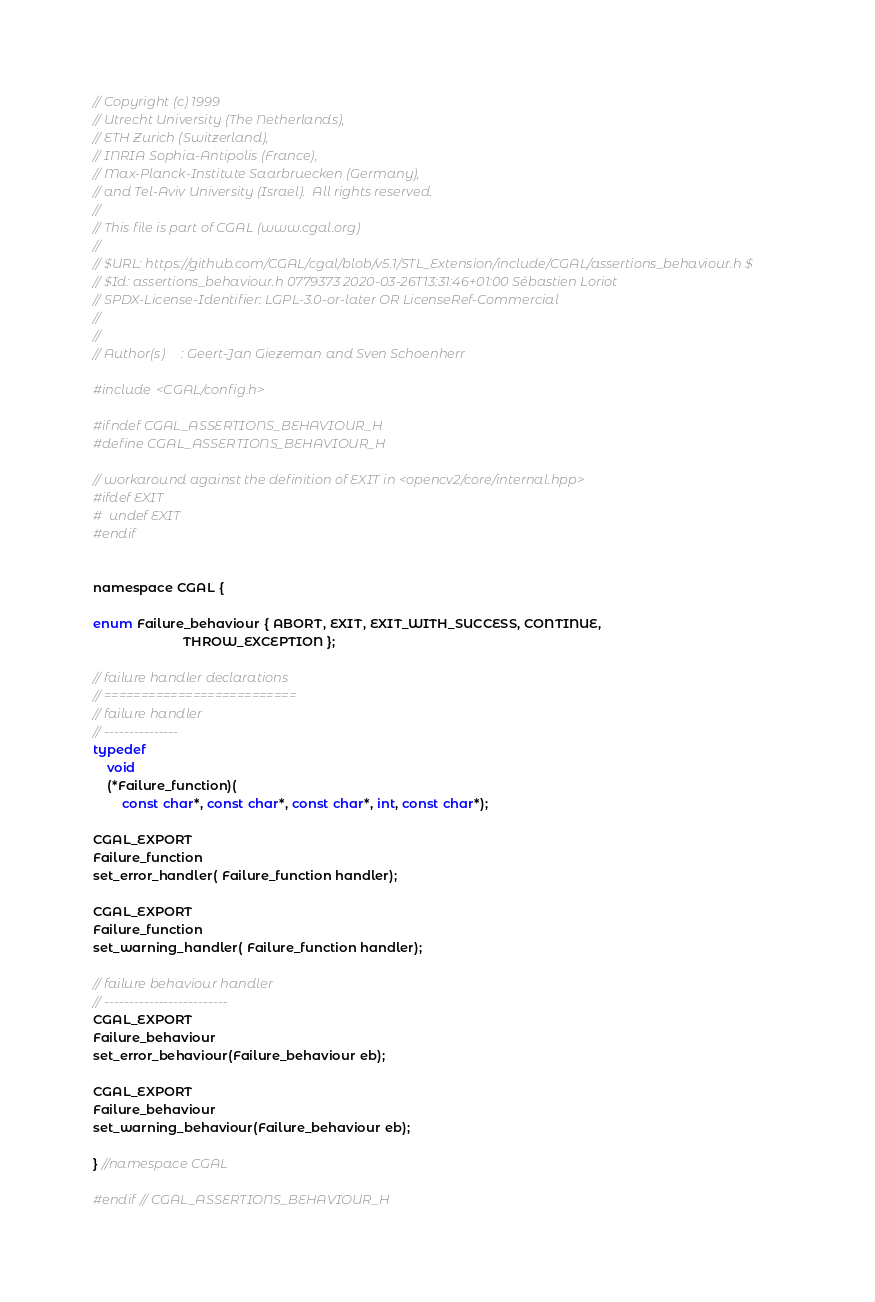<code> <loc_0><loc_0><loc_500><loc_500><_C_>// Copyright (c) 1999
// Utrecht University (The Netherlands),
// ETH Zurich (Switzerland),
// INRIA Sophia-Antipolis (France),
// Max-Planck-Institute Saarbruecken (Germany),
// and Tel-Aviv University (Israel).  All rights reserved.
//
// This file is part of CGAL (www.cgal.org)
//
// $URL: https://github.com/CGAL/cgal/blob/v5.1/STL_Extension/include/CGAL/assertions_behaviour.h $
// $Id: assertions_behaviour.h 0779373 2020-03-26T13:31:46+01:00 Sébastien Loriot
// SPDX-License-Identifier: LGPL-3.0-or-later OR LicenseRef-Commercial
//
//
// Author(s)     : Geert-Jan Giezeman and Sven Schoenherr

#include <CGAL/config.h>

#ifndef CGAL_ASSERTIONS_BEHAVIOUR_H
#define CGAL_ASSERTIONS_BEHAVIOUR_H

// workaround against the definition of EXIT in <opencv2/core/internal.hpp>
#ifdef EXIT
#  undef EXIT
#endif


namespace CGAL {

enum Failure_behaviour { ABORT, EXIT, EXIT_WITH_SUCCESS, CONTINUE,
                         THROW_EXCEPTION };

// failure handler declarations
// ==========================
// failure handler
// ---------------
typedef
    void
    (*Failure_function)(
        const char*, const char*, const char*, int, const char*);

CGAL_EXPORT
Failure_function
set_error_handler( Failure_function handler);

CGAL_EXPORT
Failure_function
set_warning_handler( Failure_function handler);

// failure behaviour handler
// -------------------------
CGAL_EXPORT
Failure_behaviour
set_error_behaviour(Failure_behaviour eb);

CGAL_EXPORT
Failure_behaviour
set_warning_behaviour(Failure_behaviour eb);

} //namespace CGAL

#endif // CGAL_ASSERTIONS_BEHAVIOUR_H
</code> 